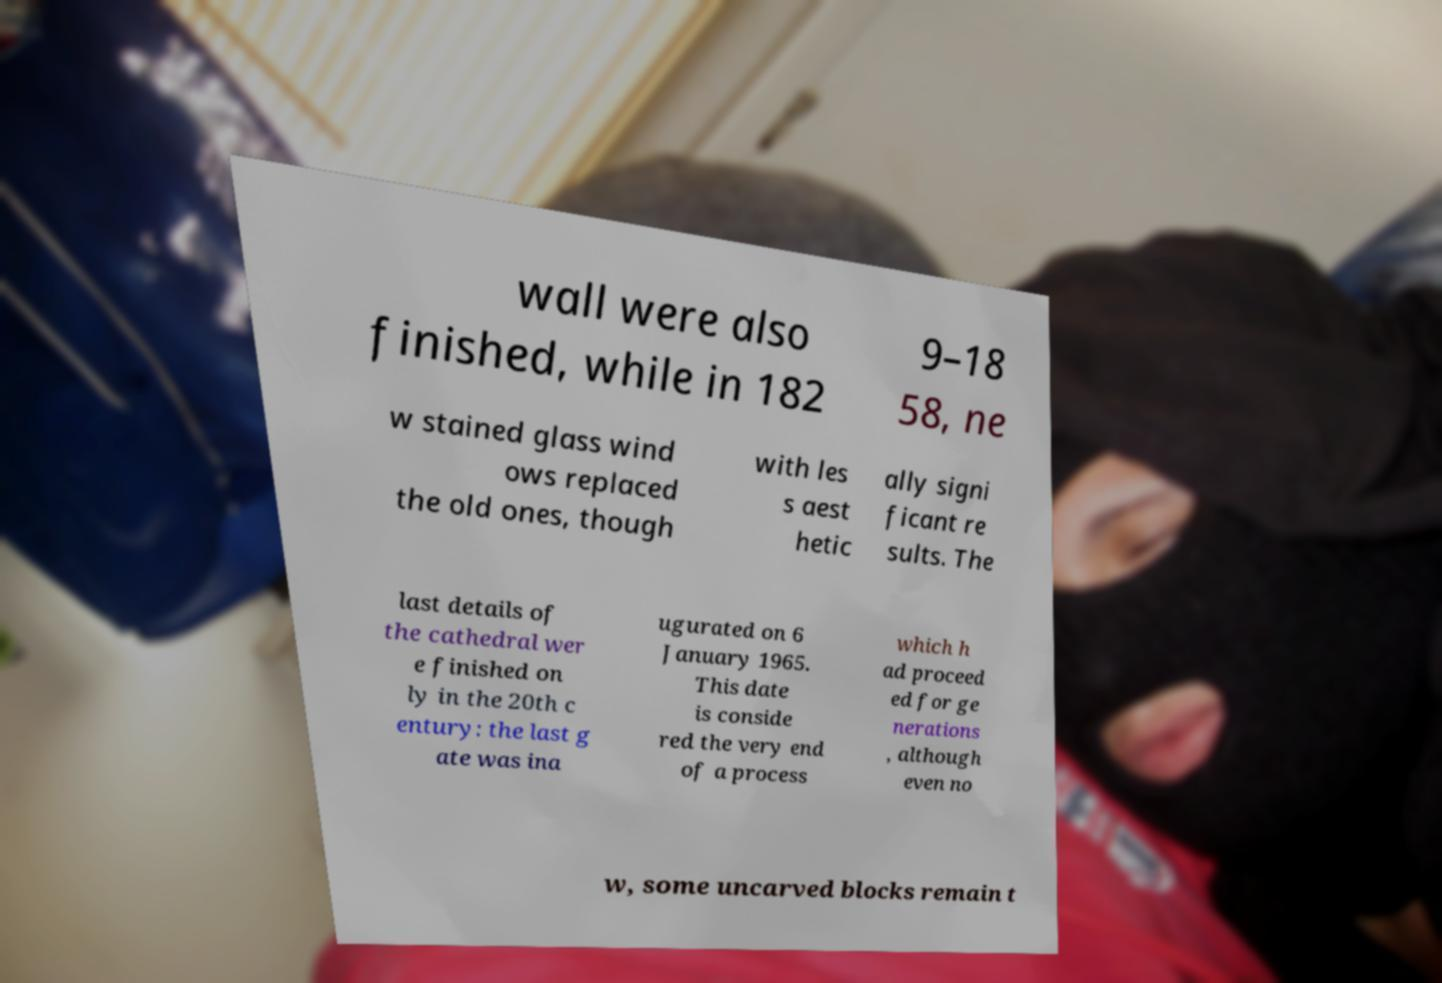Could you extract and type out the text from this image? wall were also finished, while in 182 9–18 58, ne w stained glass wind ows replaced the old ones, though with les s aest hetic ally signi ficant re sults. The last details of the cathedral wer e finished on ly in the 20th c entury: the last g ate was ina ugurated on 6 January 1965. This date is conside red the very end of a process which h ad proceed ed for ge nerations , although even no w, some uncarved blocks remain t 